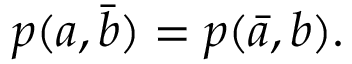<formula> <loc_0><loc_0><loc_500><loc_500>\begin{array} { r } { p ( a , \bar { b } ) = p ( \bar { a } , b ) . } \end{array}</formula> 